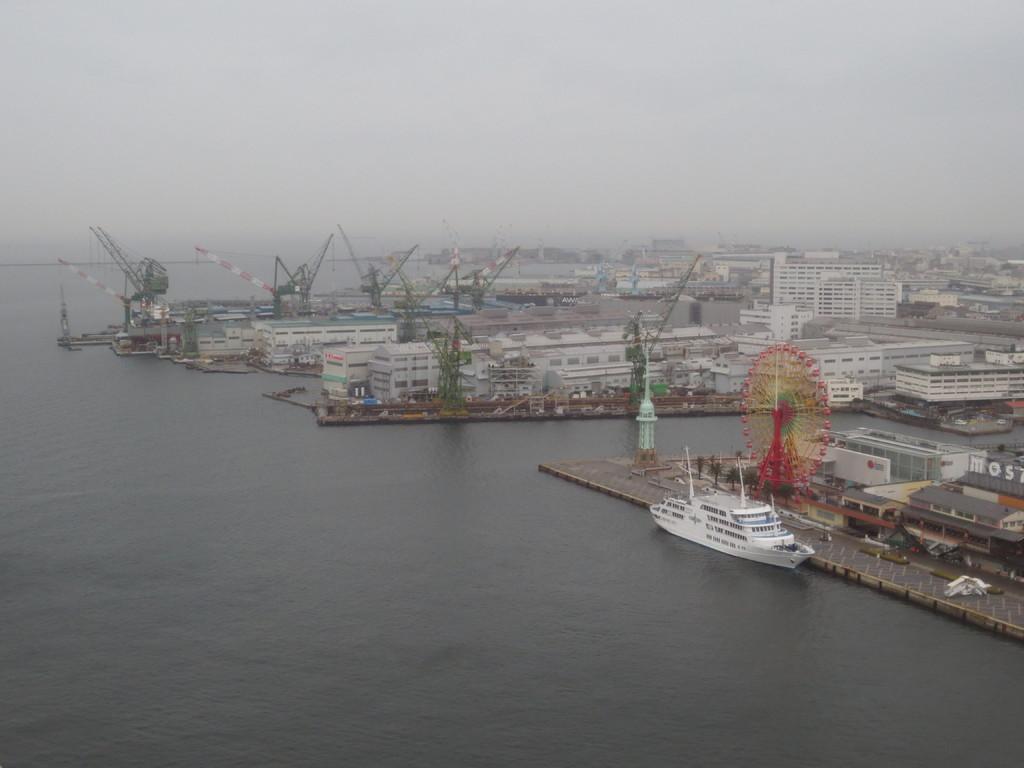Could you give a brief overview of what you see in this image? In this image there is a sea in the middle. Beside the sea there are buildings and cranes in between them. On the right side there is a Giant wheel on the ground. Beside the giant wheel there is a ship in the water. At the top there is the sky. In the background there are so many buildings. 